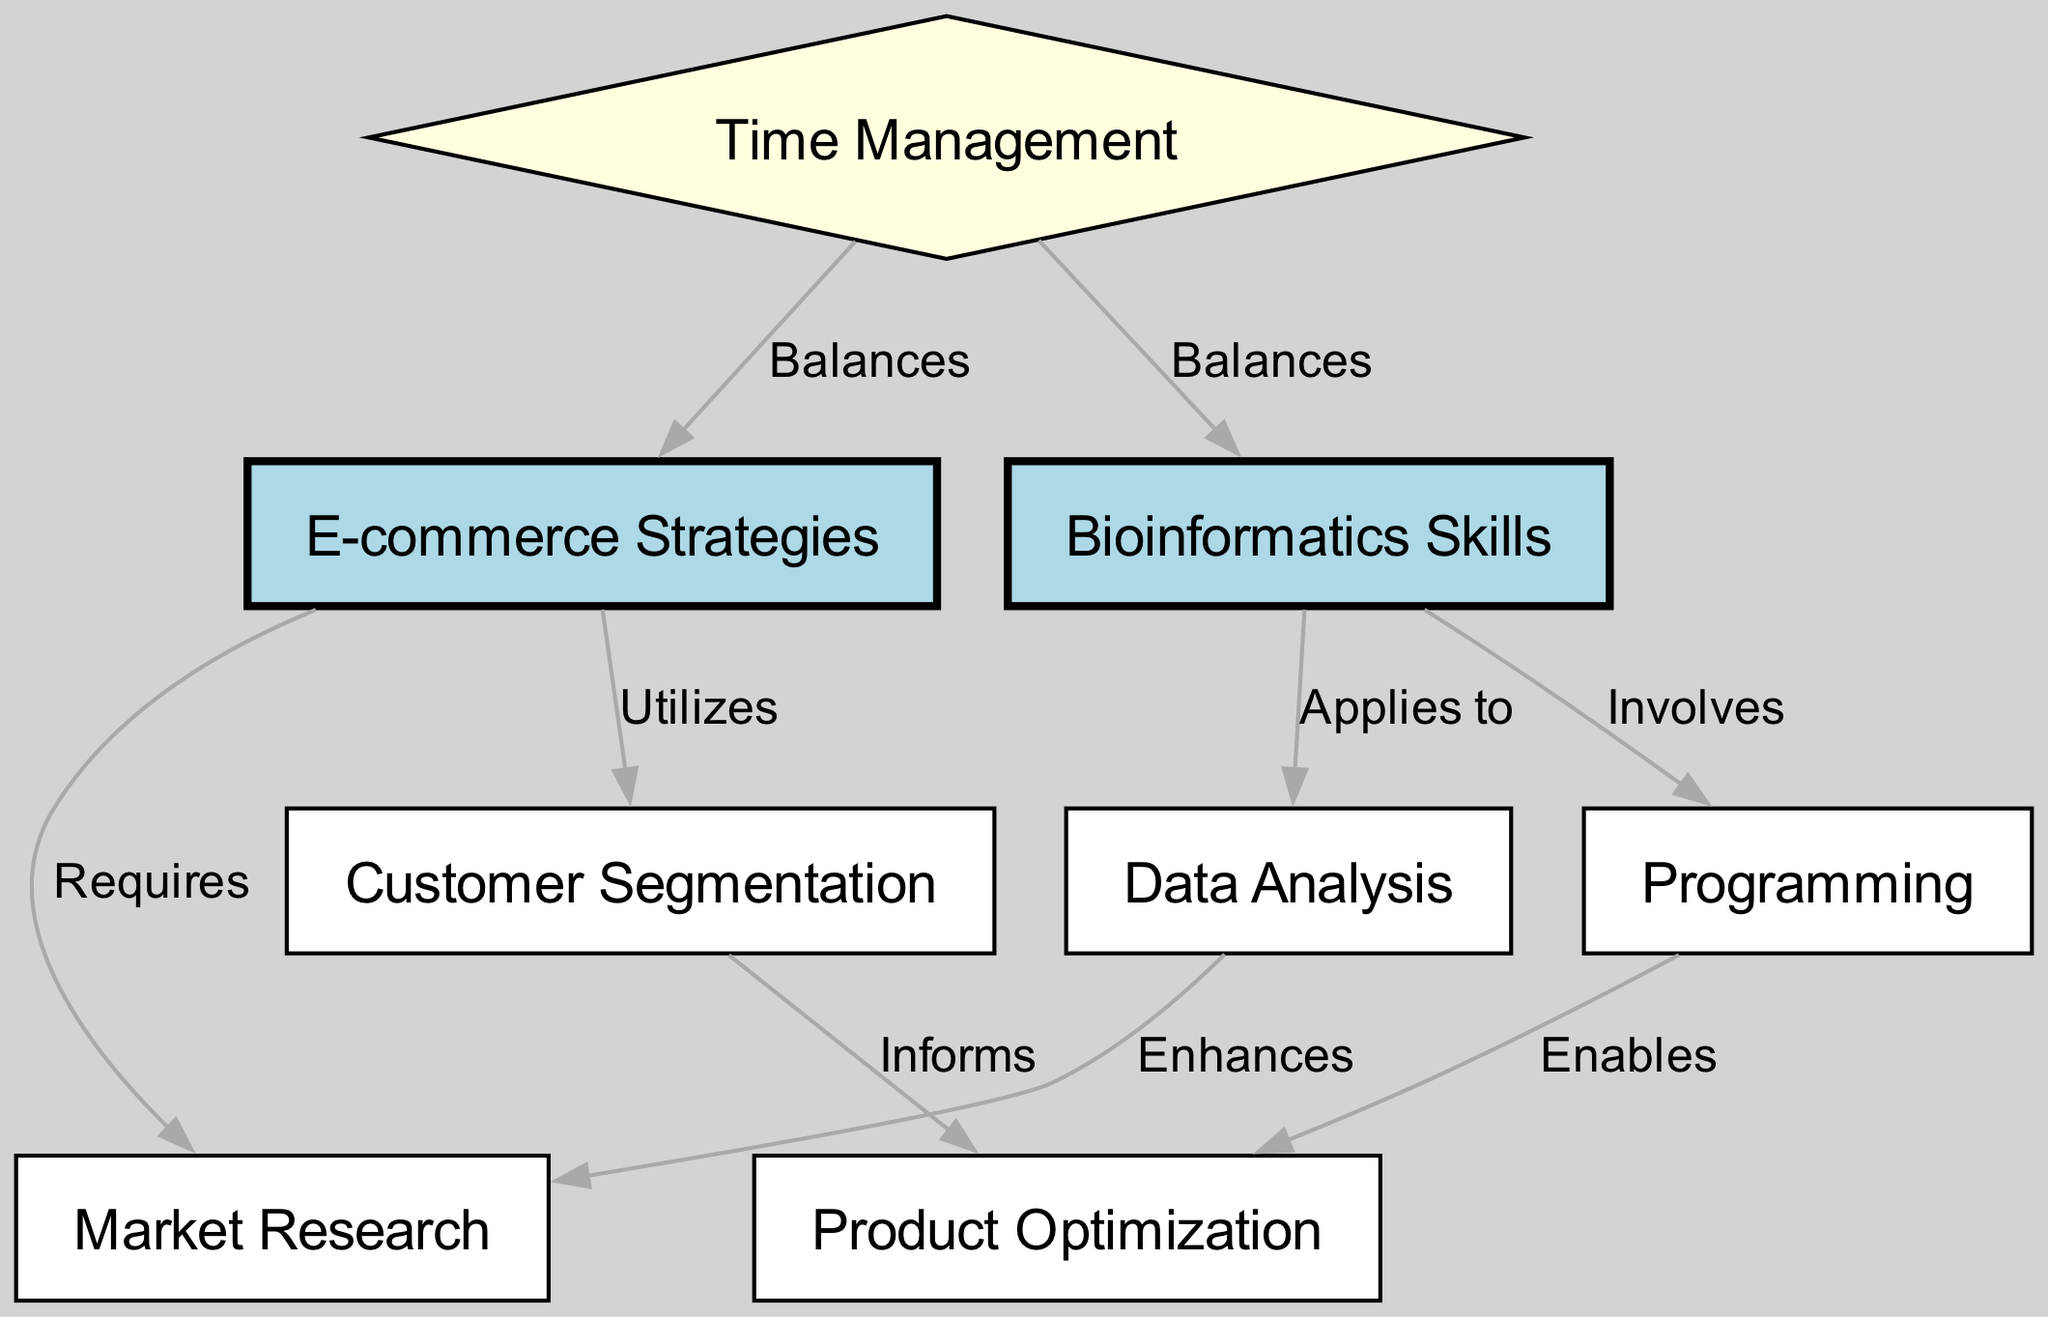What are the main components of the diagram? The diagram consists of eight nodes representing various skills and strategies related to bioinformatics and e-commerce. These nodes are "Bioinformatics Skills," "E-commerce Strategies," "Data Analysis," "Programming," "Market Research," "Customer Segmentation," "Product Optimization," and "Time Management."
Answer: Eight nodes Which node represents 'Time Management'? The node labeled "Time Management" is identified directly as such in the diagram. It has a distinct shape as a diamond and is painted light yellow, helping it stand out from the other nodes.
Answer: Time Management How many edges connect to the 'Bioinformatics Skills' node? Tracing the edges connected to the "Bioinformatics Skills" node, specifically, there are three connecting edges leading to "Data Analysis," "Programming," and "Time Management." Counting these gives us three edges.
Answer: Three edges What relationship exists between 'Data Analysis' and 'Market Research'? The edge connecting "Data Analysis" to "Market Research" is labeled “Enhances,” indicating that Data Analysis improves or contributes positively to Market Research.
Answer: Enhances Which skill directly informs 'Product Optimization'? The node "Customer Segmentation" is connected to "Product Optimization" with an edge labeled "Informs," signifying that it provides valuable insights or information to optimize products.
Answer: Customer Segmentation What role does 'Programming' play in relation to 'Product Optimization'? The label on the edge connecting "Programming" to "Product Optimization" states "Enables," which indicates that Programming serves a supportive role that allows or facilitates the process of optimizing products.
Answer: Enables What two strategies does 'Time Management' balance? The edges from "Time Management" connect to both "Bioinformatics Skills" and "E-commerce Strategies," indicating that it plays a balancing role for both disciplines.
Answer: Bioinformatics Skills and E-commerce Strategies Which skill is utilized by 'E-commerce Strategies'? The diagram shows that "Customer Segmentation" is connected to the "E-commerce Strategies" node, and the edge is labeled "Utilizes," indicating Customer Segmentation is a key element employed in E-commerce strategies.
Answer: Customer Segmentation 